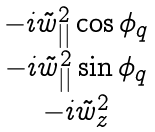<formula> <loc_0><loc_0><loc_500><loc_500>\begin{matrix} - i \tilde { w } ^ { 2 } _ { | | } \cos \phi _ { q } \\ - i \tilde { w } ^ { 2 } _ { | | } \sin \phi _ { q } \\ - i \tilde { w } ^ { 2 } _ { z } \end{matrix}</formula> 